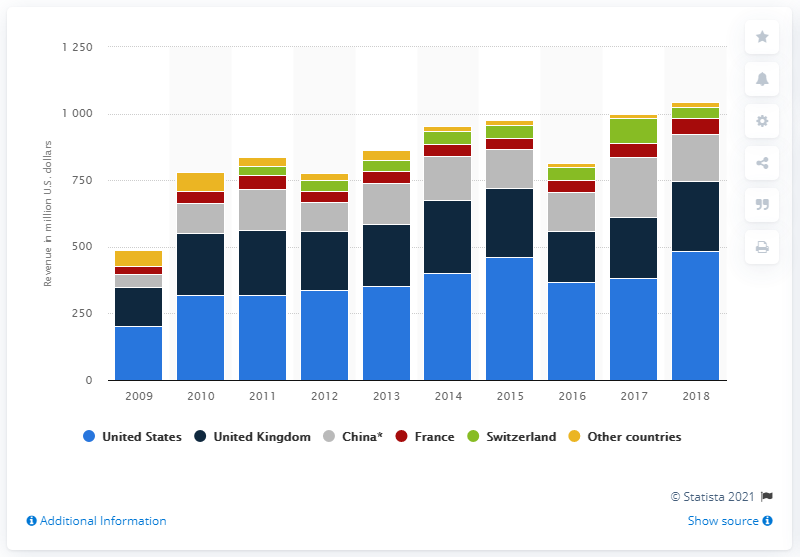Indicate a few pertinent items in this graphic. In 2018, Sotheby's generated a revenue of approximately $484.28 million in the United States. 